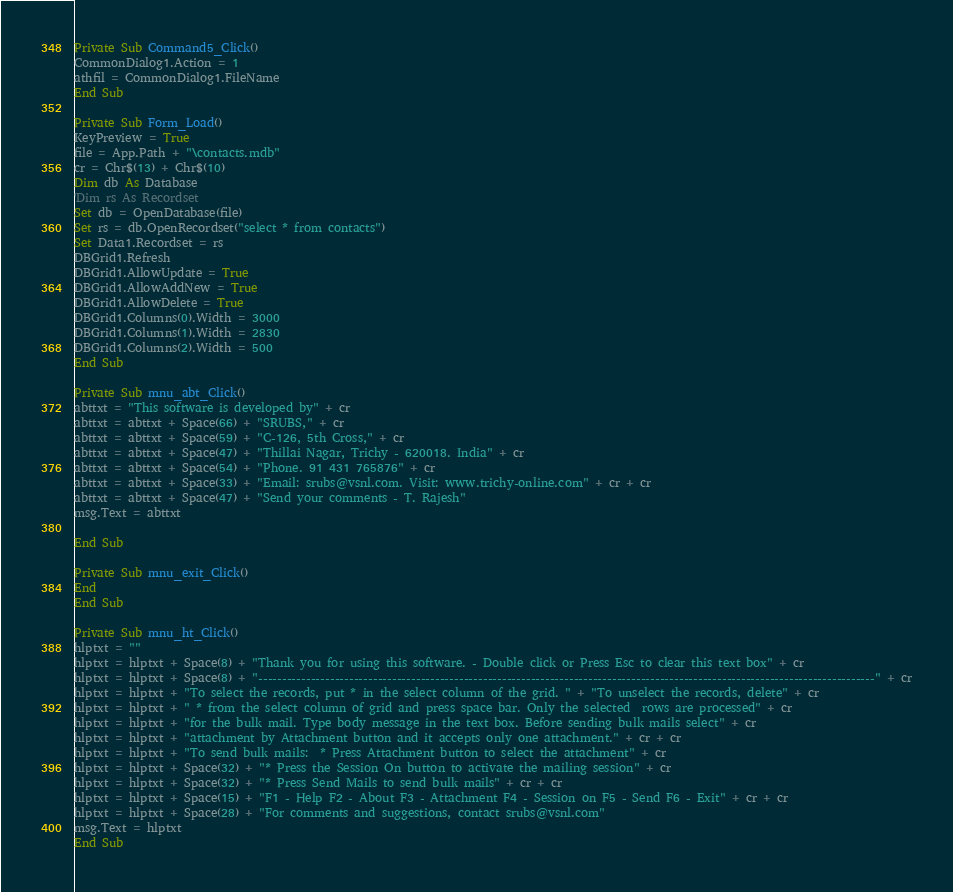Convert code to text. <code><loc_0><loc_0><loc_500><loc_500><_VisualBasic_>
Private Sub Command5_Click()
CommonDialog1.Action = 1
athfil = CommonDialog1.FileName
End Sub

Private Sub Form_Load()
KeyPreview = True
file = App.Path + "\contacts.mdb"
cr = Chr$(13) + Chr$(10)
Dim db As Database
'Dim rs As Recordset
Set db = OpenDatabase(file)
Set rs = db.OpenRecordset("select * from contacts")
Set Data1.Recordset = rs
DBGrid1.Refresh
DBGrid1.AllowUpdate = True
DBGrid1.AllowAddNew = True
DBGrid1.AllowDelete = True
DBGrid1.Columns(0).Width = 3000
DBGrid1.Columns(1).Width = 2830
DBGrid1.Columns(2).Width = 500
End Sub

Private Sub mnu_abt_Click()
abttxt = "This software is developed by" + cr
abttxt = abttxt + Space(66) + "SRUBS," + cr
abttxt = abttxt + Space(59) + "C-126, 5th Cross," + cr
abttxt = abttxt + Space(47) + "Thillai Nagar, Trichy - 620018. India" + cr
abttxt = abttxt + Space(54) + "Phone. 91 431 765876" + cr
abttxt = abttxt + Space(33) + "Email: srubs@vsnl.com. Visit: www.trichy-online.com" + cr + cr
abttxt = abttxt + Space(47) + "Send your comments - T. Rajesh"
msg.Text = abttxt

End Sub

Private Sub mnu_exit_Click()
End
End Sub

Private Sub mnu_ht_Click()
hlptxt = ""
hlptxt = hlptxt + Space(8) + "Thank you for using this software. - Double click or Press Esc to clear this text box" + cr
hlptxt = hlptxt + Space(8) + "---------------------------------------------------------------------------------------------------------------------------------" + cr
hlptxt = hlptxt + "To select the records, put * in the select column of the grid. " + "To unselect the records, delete" + cr
hlptxt = hlptxt + " * from the select column of grid and press space bar. Only the selected  rows are processed" + cr
hlptxt = hlptxt + "for the bulk mail. Type body message in the text box. Before sending bulk mails select" + cr
hlptxt = hlptxt + "attachment by Attachment button and it accepts only one attachment." + cr + cr
hlptxt = hlptxt + "To send bulk mails:  * Press Attachment button to select the attachment" + cr
hlptxt = hlptxt + Space(32) + "* Press the Session On button to activate the mailing session" + cr
hlptxt = hlptxt + Space(32) + "* Press Send Mails to send bulk mails" + cr + cr
hlptxt = hlptxt + Space(15) + "F1 - Help F2 - About F3 - Attachment F4 - Session on F5 - Send F6 - Exit" + cr + cr
hlptxt = hlptxt + Space(28) + "For comments and suggestions, contact srubs@vsnl.com"
msg.Text = hlptxt
End Sub
</code> 